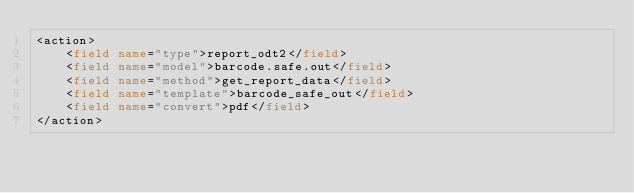Convert code to text. <code><loc_0><loc_0><loc_500><loc_500><_XML_><action>
    <field name="type">report_odt2</field>
    <field name="model">barcode.safe.out</field>
    <field name="method">get_report_data</field>
    <field name="template">barcode_safe_out</field>
    <field name="convert">pdf</field>
</action>

</code> 